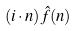Convert formula to latex. <formula><loc_0><loc_0><loc_500><loc_500>( i \cdot n ) \hat { f } ( n )</formula> 